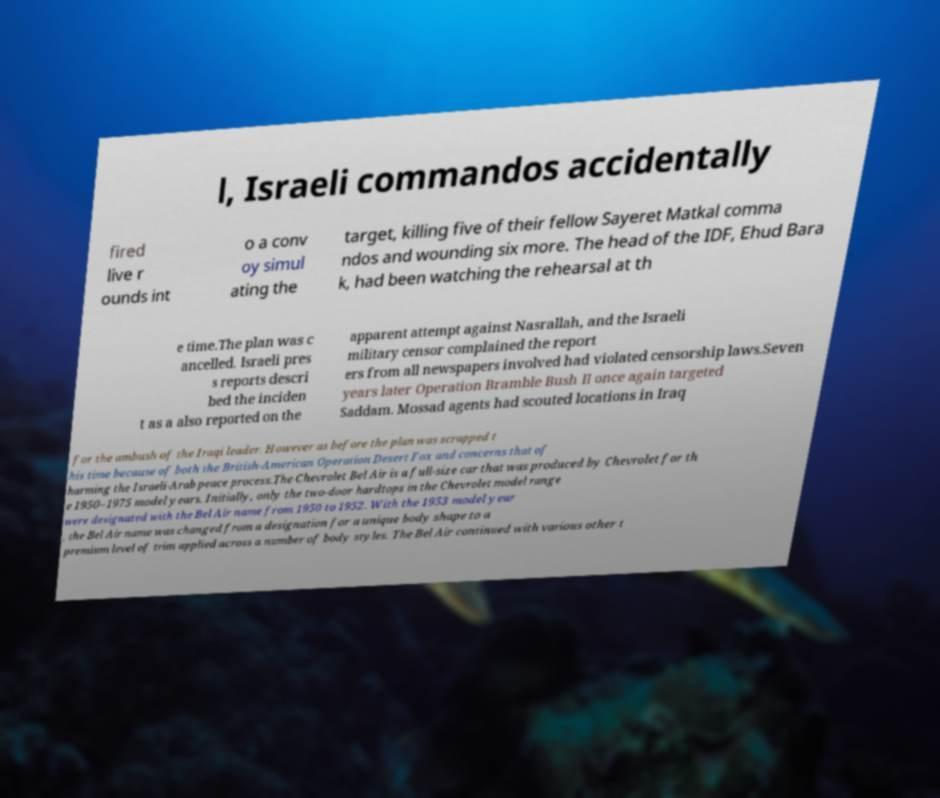Could you extract and type out the text from this image? l, Israeli commandos accidentally fired live r ounds int o a conv oy simul ating the target, killing five of their fellow Sayeret Matkal comma ndos and wounding six more. The head of the IDF, Ehud Bara k, had been watching the rehearsal at th e time.The plan was c ancelled. Israeli pres s reports descri bed the inciden t as a also reported on the apparent attempt against Nasrallah, and the Israeli military censor complained the report ers from all newspapers involved had violated censorship laws.Seven years later Operation Bramble Bush II once again targeted Saddam. Mossad agents had scouted locations in Iraq for the ambush of the Iraqi leader. However as before the plan was scrapped t his time because of both the British-American Operation Desert Fox and concerns that of harming the Israeli-Arab peace process.The Chevrolet Bel Air is a full-size car that was produced by Chevrolet for th e 1950–1975 model years. Initially, only the two-door hardtops in the Chevrolet model range were designated with the Bel Air name from 1950 to 1952. With the 1953 model year , the Bel Air name was changed from a designation for a unique body shape to a premium level of trim applied across a number of body styles. The Bel Air continued with various other t 